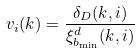Convert formula to latex. <formula><loc_0><loc_0><loc_500><loc_500>v _ { i } ( k ) = \frac { \delta _ { D } ( k , i ) } { \xi _ { b _ { \min } } ^ { d } ( k , i ) }</formula> 